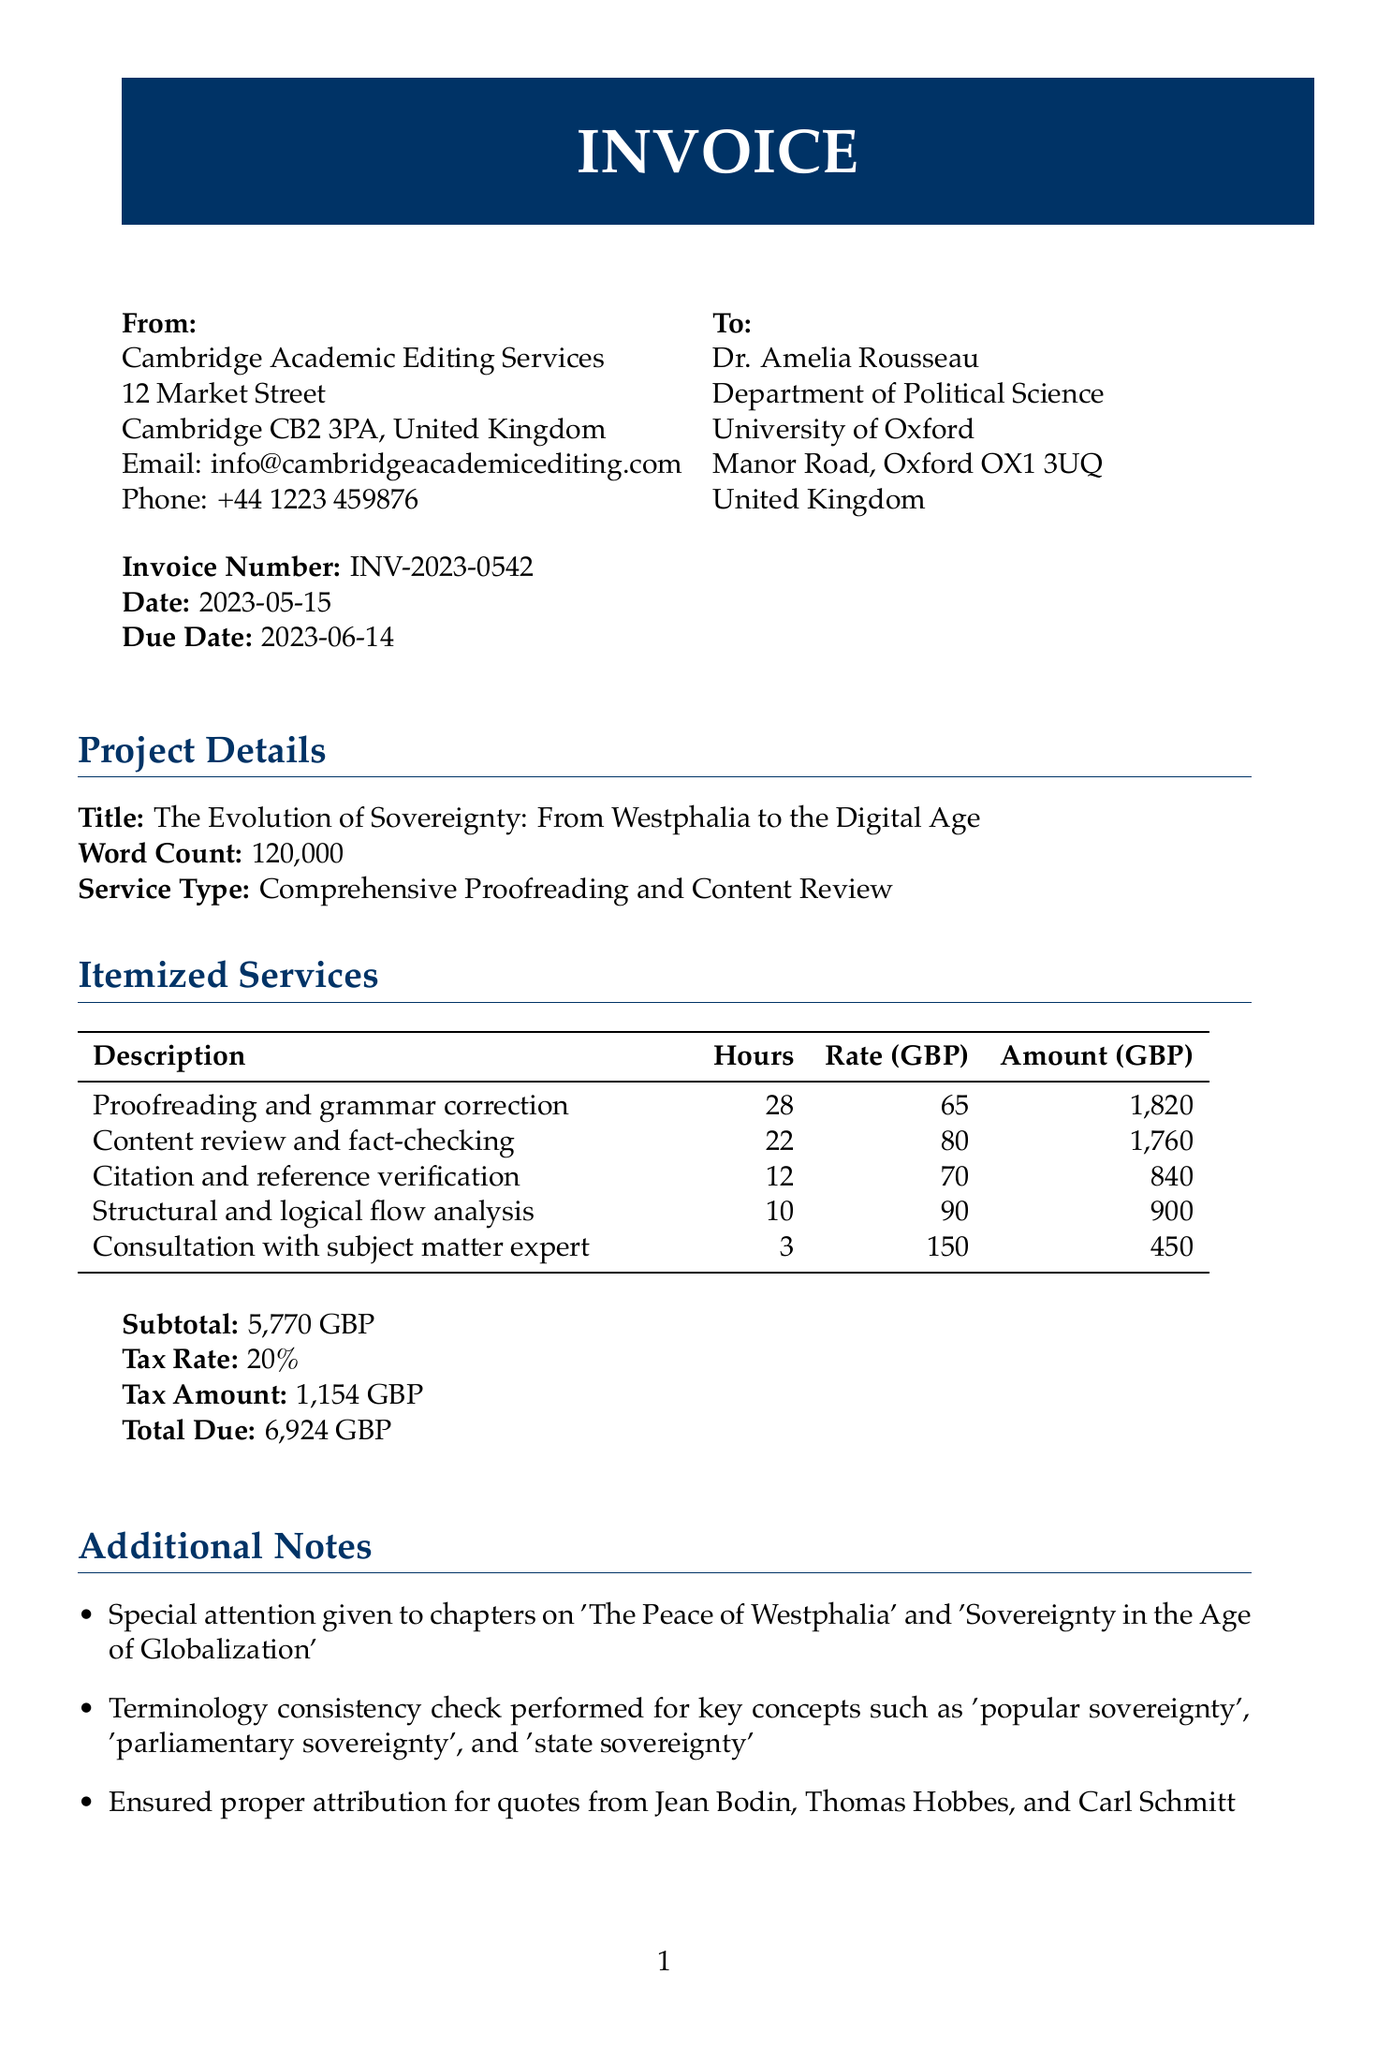what is the invoice number? The invoice number is a unique identifier for this invoice document, located in the top section of the invoice.
Answer: INV-2023-0542 who is the client? The client is the individual or organization receiving the invoice, specified in the recipient section.
Answer: Dr. Amelia Rousseau what is the due date for payment? The due date is the deadline by which payment should be made, provided in the invoice details.
Answer: 2023-06-14 how many hours were spent on proofreading and grammar correction? The number of hours spent on this specific service is mentioned in the itemized services table.
Answer: 28 what is the total due amount? The total due amount is the final figure that the client needs to pay, calculated based on services rendered and applicable taxes.
Answer: 6924 GBP what was the hourly rate for consultation with the subject matter expert? The hourly rate for this service is explicitly stated in the itemized services section.
Answer: 150 how many hours were allocated for content review and fact-checking? This refers to the specific hours designated for this service, noted in the itemized services table.
Answer: 22 which chapters received special attention during the review? This information details specific topics highlighted for additional focus in the project notes section.
Answer: 'The Peace of Westphalia' and 'Sovereignty in the Age of Globalization' what payment method is specified for this invoice? The payment method outlines how the client should make their payment, detailed at the end of the document.
Answer: Bank transfer to Barclays Bank 